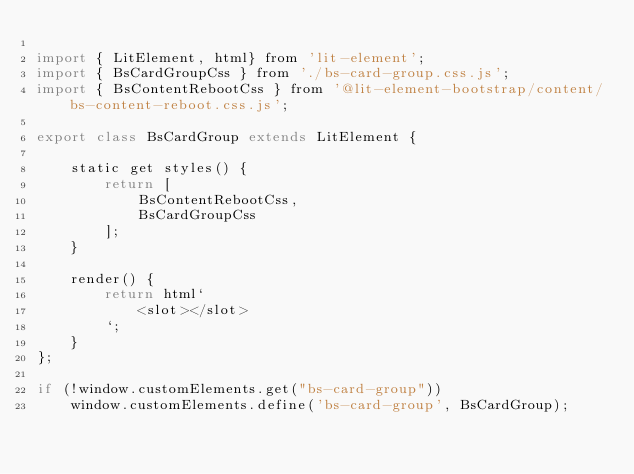Convert code to text. <code><loc_0><loc_0><loc_500><loc_500><_JavaScript_>
import { LitElement, html} from 'lit-element';
import { BsCardGroupCss } from './bs-card-group.css.js';
import { BsContentRebootCss } from '@lit-element-bootstrap/content/bs-content-reboot.css.js';

export class BsCardGroup extends LitElement {

    static get styles() {
        return [
            BsContentRebootCss,
            BsCardGroupCss
        ];
    }

    render() {
        return html`
            <slot></slot>
        `;
    }
};

if (!window.customElements.get("bs-card-group"))
    window.customElements.define('bs-card-group', BsCardGroup);
</code> 